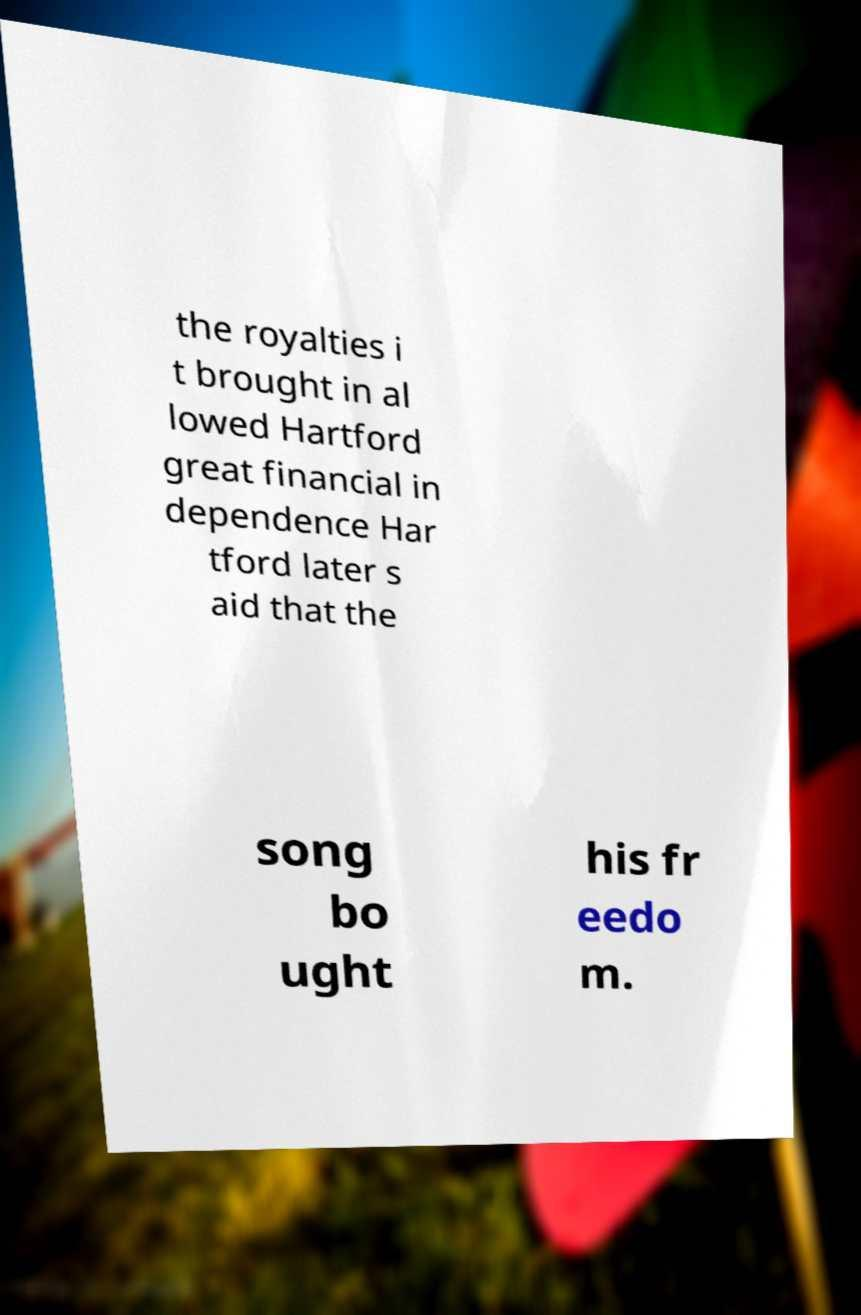Could you assist in decoding the text presented in this image and type it out clearly? the royalties i t brought in al lowed Hartford great financial in dependence Har tford later s aid that the song bo ught his fr eedo m. 